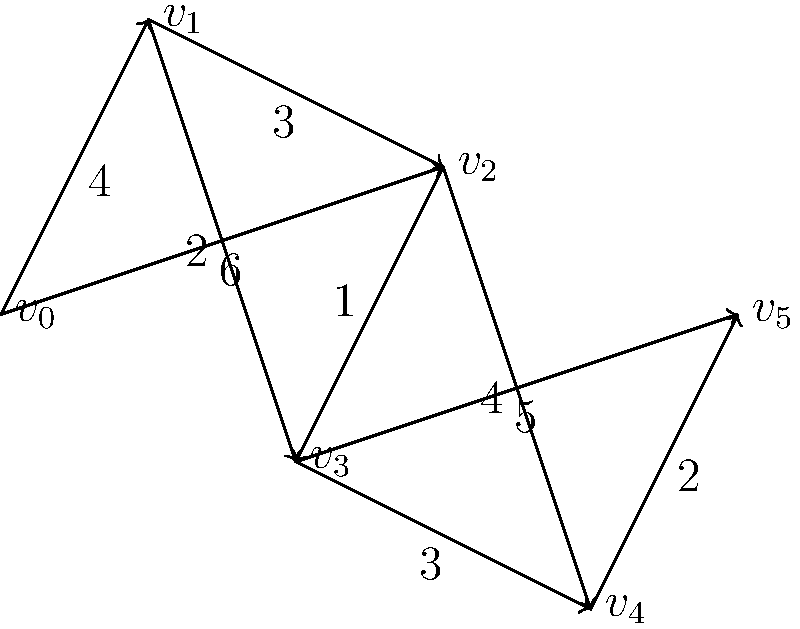In a network of trauma treatment centers, each vertex represents a center, and each edge represents a referral path between centers, with the weight indicating the average time (in days) for patient transfer. What is the shortest path from center $v_0$ to center $v_5$, and what is the total transfer time along this path? To find the shortest path from $v_0$ to $v_5$, we can use Dijkstra's algorithm:

1. Initialize:
   - Distance to $v_0$ = 0
   - Distance to all other vertices = $\infty$

2. Visit $v_0$:
   - Update: $d(v_1) = 4$, $d(v_2) = 6$

3. Visit $v_1$ (closest unvisited vertex):
   - Update: $d(v_2) = \min(6, 4+3) = 6$, $d(v_3) = 4+2 = 6$

4. Visit $v_2$ (closest unvisited vertex):
   - Update: $d(v_3) = \min(6, 6+1) = 6$, $d(v_4) = 6+4 = 10$

5. Visit $v_3$ (closest unvisited vertex):
   - Update: $d(v_4) = \min(10, 6+3) = 9$, $d(v_5) = 6+5 = 11$

6. Visit $v_4$ (closest unvisited vertex):
   - Update: $d(v_5) = \min(11, 9+2) = 11$

7. Visit $v_5$ (destination reached)

The shortest path is $v_0 \to v_1 \to v_3 \to v_5$ with a total transfer time of 11 days.
Answer: $v_0 \to v_1 \to v_3 \to v_5$, 11 days 